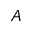<formula> <loc_0><loc_0><loc_500><loc_500>A</formula> 